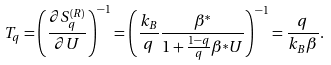<formula> <loc_0><loc_0><loc_500><loc_500>T _ { q } = \left ( \frac { \partial S _ { q } ^ { ( R ) } } { \partial U } \right ) ^ { - 1 } = \left ( \frac { k _ { B } } { q } \frac { \beta ^ { * } } { 1 + \frac { 1 - q } { q } \beta ^ { * } U } \right ) ^ { - 1 } = \frac { q } { k _ { B } \beta } .</formula> 